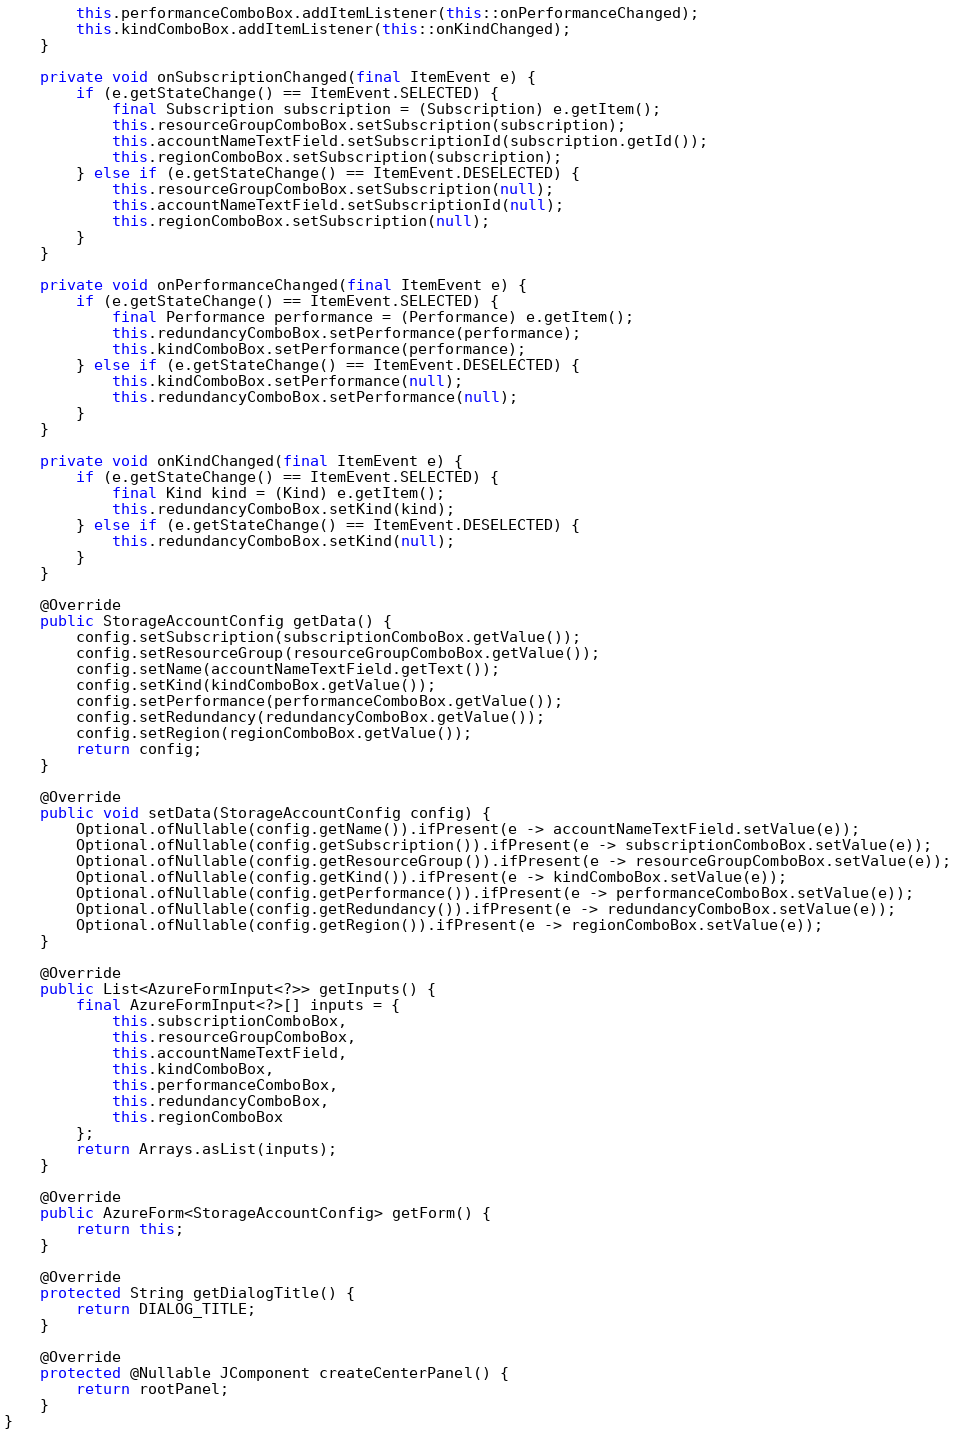<code> <loc_0><loc_0><loc_500><loc_500><_Java_>        this.performanceComboBox.addItemListener(this::onPerformanceChanged);
        this.kindComboBox.addItemListener(this::onKindChanged);
    }

    private void onSubscriptionChanged(final ItemEvent e) {
        if (e.getStateChange() == ItemEvent.SELECTED) {
            final Subscription subscription = (Subscription) e.getItem();
            this.resourceGroupComboBox.setSubscription(subscription);
            this.accountNameTextField.setSubscriptionId(subscription.getId());
            this.regionComboBox.setSubscription(subscription);
        } else if (e.getStateChange() == ItemEvent.DESELECTED) {
            this.resourceGroupComboBox.setSubscription(null);
            this.accountNameTextField.setSubscriptionId(null);
            this.regionComboBox.setSubscription(null);
        }
    }

    private void onPerformanceChanged(final ItemEvent e) {
        if (e.getStateChange() == ItemEvent.SELECTED) {
            final Performance performance = (Performance) e.getItem();
            this.redundancyComboBox.setPerformance(performance);
            this.kindComboBox.setPerformance(performance);
        } else if (e.getStateChange() == ItemEvent.DESELECTED) {
            this.kindComboBox.setPerformance(null);
            this.redundancyComboBox.setPerformance(null);
        }
    }

    private void onKindChanged(final ItemEvent e) {
        if (e.getStateChange() == ItemEvent.SELECTED) {
            final Kind kind = (Kind) e.getItem();
            this.redundancyComboBox.setKind(kind);
        } else if (e.getStateChange() == ItemEvent.DESELECTED) {
            this.redundancyComboBox.setKind(null);
        }
    }

    @Override
    public StorageAccountConfig getData() {
        config.setSubscription(subscriptionComboBox.getValue());
        config.setResourceGroup(resourceGroupComboBox.getValue());
        config.setName(accountNameTextField.getText());
        config.setKind(kindComboBox.getValue());
        config.setPerformance(performanceComboBox.getValue());
        config.setRedundancy(redundancyComboBox.getValue());
        config.setRegion(regionComboBox.getValue());
        return config;
    }

    @Override
    public void setData(StorageAccountConfig config) {
        Optional.ofNullable(config.getName()).ifPresent(e -> accountNameTextField.setValue(e));
        Optional.ofNullable(config.getSubscription()).ifPresent(e -> subscriptionComboBox.setValue(e));
        Optional.ofNullable(config.getResourceGroup()).ifPresent(e -> resourceGroupComboBox.setValue(e));
        Optional.ofNullable(config.getKind()).ifPresent(e -> kindComboBox.setValue(e));
        Optional.ofNullable(config.getPerformance()).ifPresent(e -> performanceComboBox.setValue(e));
        Optional.ofNullable(config.getRedundancy()).ifPresent(e -> redundancyComboBox.setValue(e));
        Optional.ofNullable(config.getRegion()).ifPresent(e -> regionComboBox.setValue(e));
    }

    @Override
    public List<AzureFormInput<?>> getInputs() {
        final AzureFormInput<?>[] inputs = {
            this.subscriptionComboBox,
            this.resourceGroupComboBox,
            this.accountNameTextField,
            this.kindComboBox,
            this.performanceComboBox,
            this.redundancyComboBox,
            this.regionComboBox
        };
        return Arrays.asList(inputs);
    }

    @Override
    public AzureForm<StorageAccountConfig> getForm() {
        return this;
    }

    @Override
    protected String getDialogTitle() {
        return DIALOG_TITLE;
    }

    @Override
    protected @Nullable JComponent createCenterPanel() {
        return rootPanel;
    }
}
</code> 